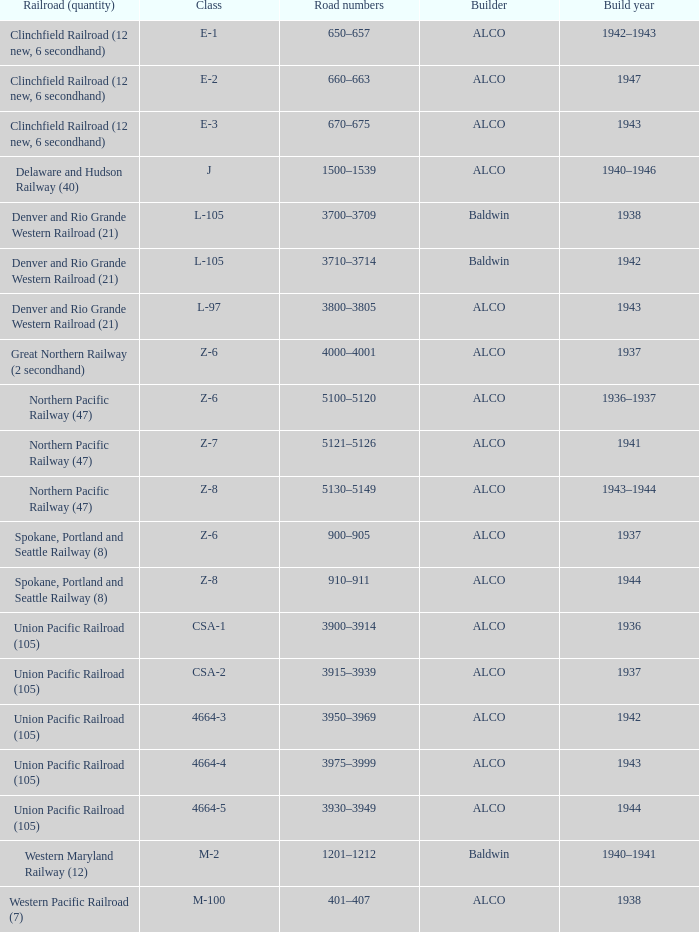What is the road numbers when the builder is alco, the railroad (quantity) is union pacific railroad (105) and the class is csa-2? 3915–3939. 